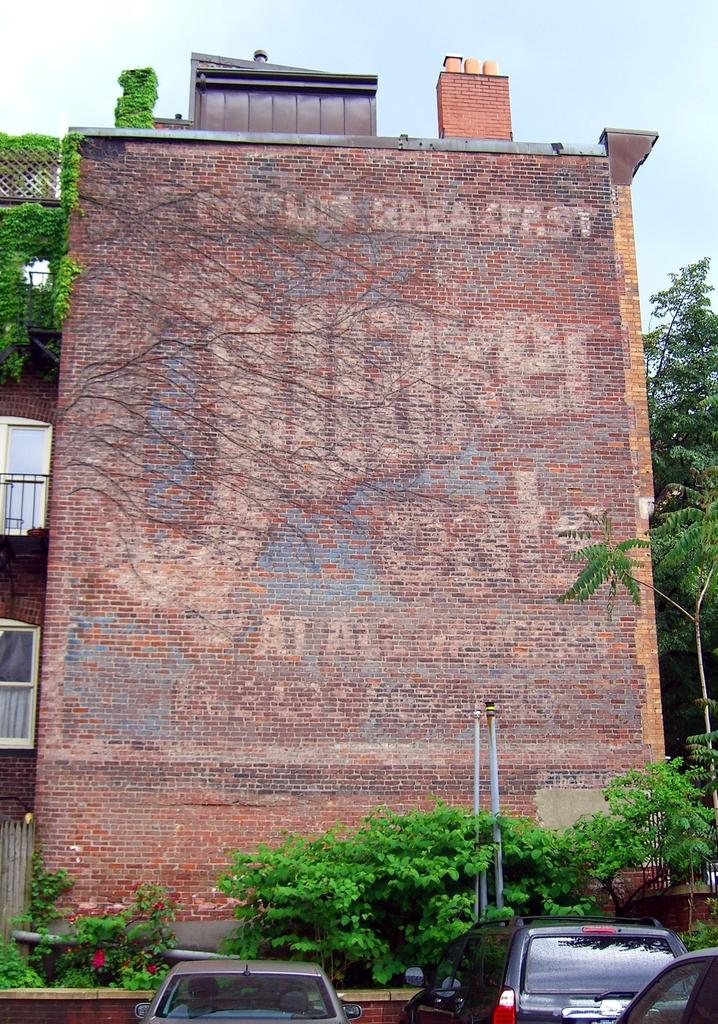What type of structure can be seen in the image? There is a building in the image. What type of vegetation is present in the image? Creepers, plants, and trees are visible in the image. What other objects can be seen in the image? Pipes and vehicles are present in the image. What part of the natural environment is visible in the image? The sky is visible in the image. How does the order of the plants in the image affect the growth of the spring? There is no mention of spring or the order of plants in the image, so this question cannot be answered definitively. 